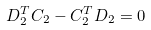Convert formula to latex. <formula><loc_0><loc_0><loc_500><loc_500>D _ { 2 } ^ { T } C _ { 2 } - C _ { 2 } ^ { T } D _ { 2 } = 0</formula> 